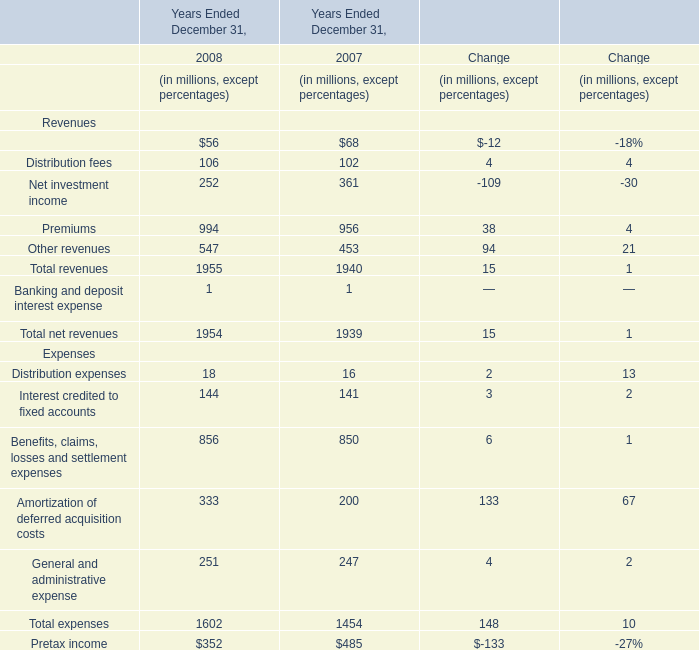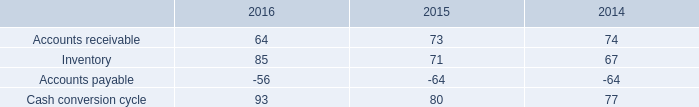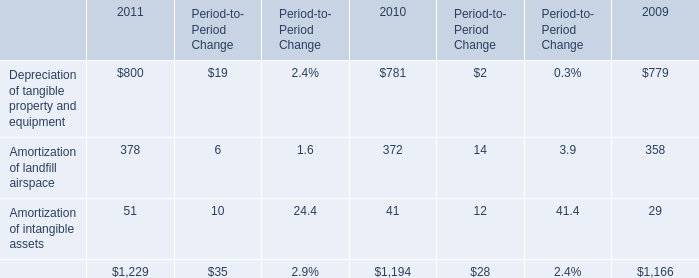How many Revenues exceed the average of Distribution fees in 2008? 
Answer: 3. 